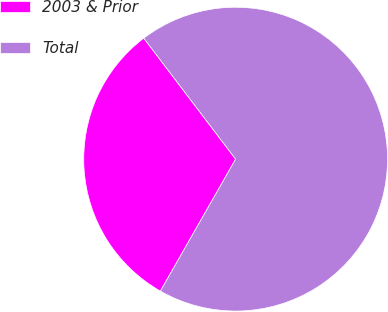<chart> <loc_0><loc_0><loc_500><loc_500><pie_chart><fcel>2003 & Prior<fcel>Total<nl><fcel>31.42%<fcel>68.58%<nl></chart> 